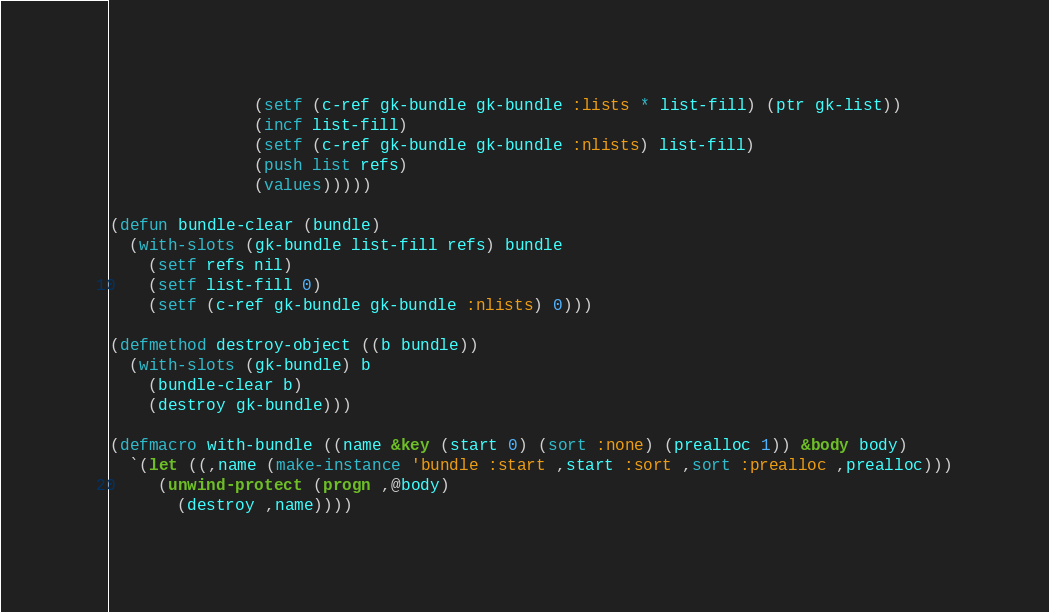Convert code to text. <code><loc_0><loc_0><loc_500><loc_500><_Lisp_>               (setf (c-ref gk-bundle gk-bundle :lists * list-fill) (ptr gk-list))
               (incf list-fill)
               (setf (c-ref gk-bundle gk-bundle :nlists) list-fill)
               (push list refs)
               (values)))))

(defun bundle-clear (bundle)
  (with-slots (gk-bundle list-fill refs) bundle
    (setf refs nil)
    (setf list-fill 0)
    (setf (c-ref gk-bundle gk-bundle :nlists) 0)))

(defmethod destroy-object ((b bundle))
  (with-slots (gk-bundle) b
    (bundle-clear b)
    (destroy gk-bundle)))

(defmacro with-bundle ((name &key (start 0) (sort :none) (prealloc 1)) &body body)
  `(let ((,name (make-instance 'bundle :start ,start :sort ,sort :prealloc ,prealloc)))
     (unwind-protect (progn ,@body)
       (destroy ,name))))
</code> 